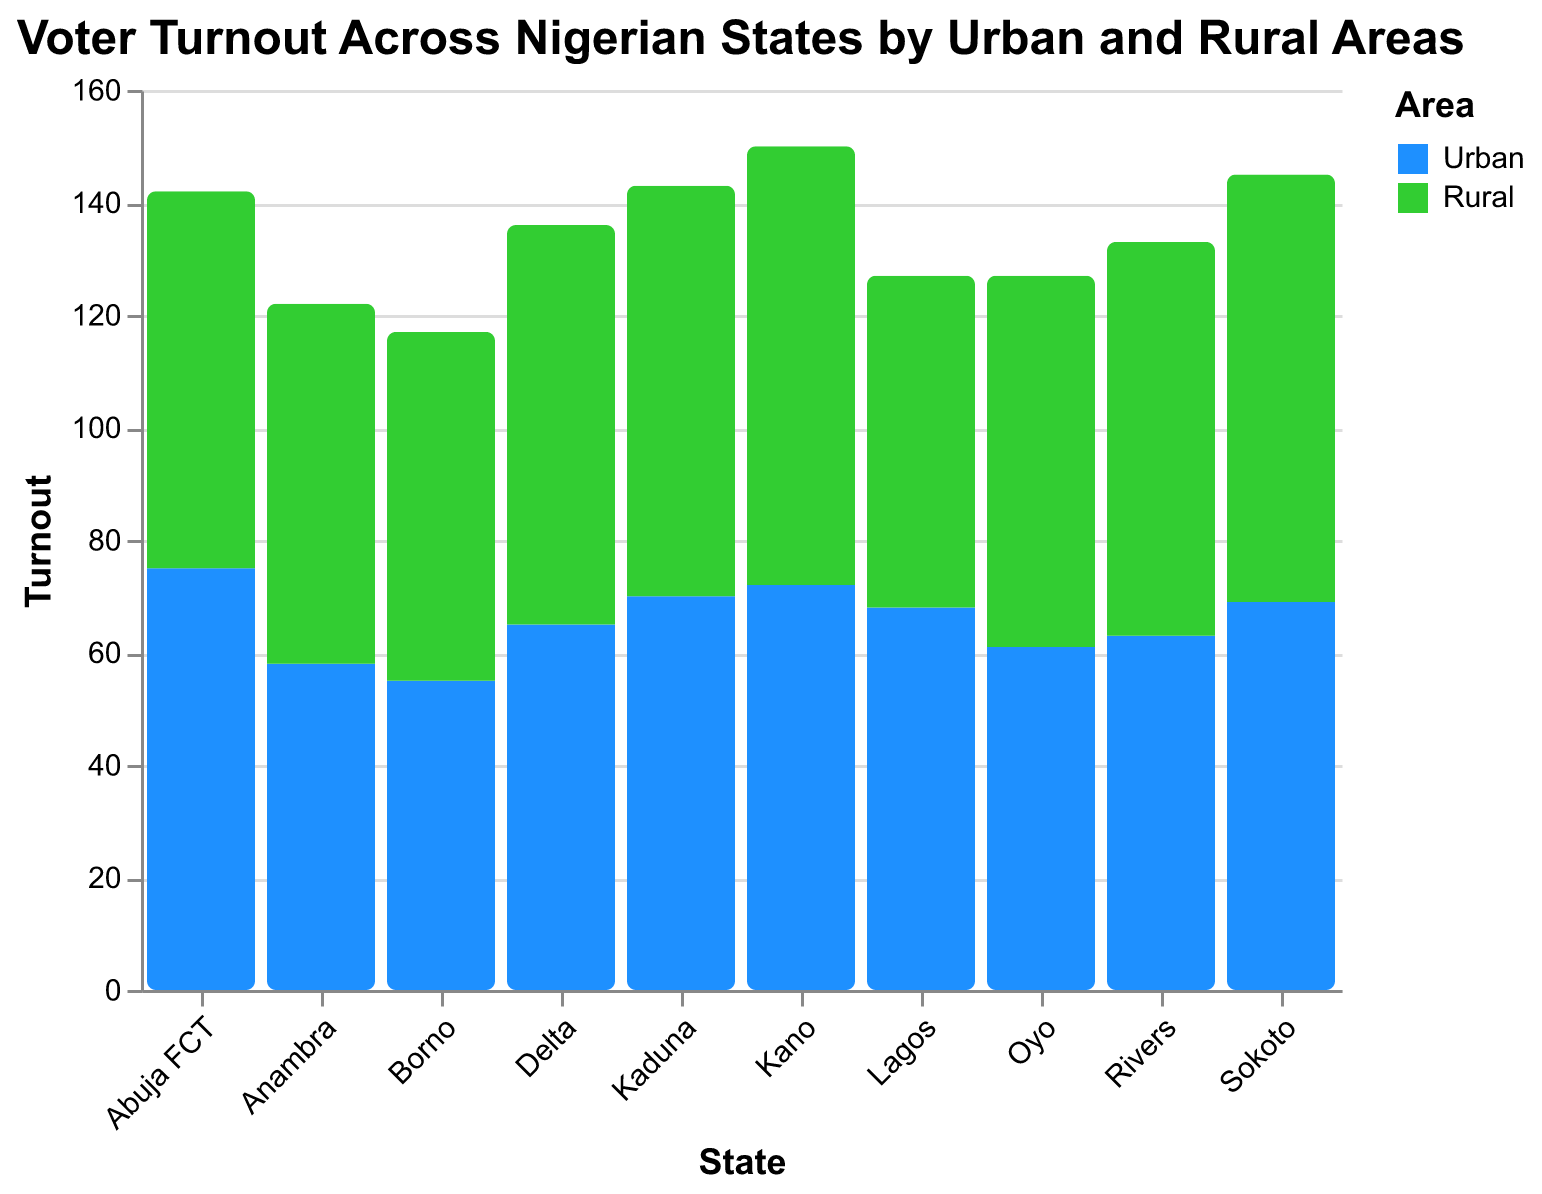What is the voter turnout in urban areas of Lagos? The voter turnout in urban areas of Lagos can be identified by finding the bar corresponding to Lagos under the color for urban areas.
Answer: 68 Which state has the highest voter turnout in rural areas? To find the state with the highest voter turnout in rural areas, compare the bar heights for all rural areas across the states.
Answer: Kano Compare the voter turnout between urban and rural areas in Rivers. Which has a higher turnout? Identify the bars for Urban and Rural areas of Rivers and compare their heights. The higher bar represents the area with the higher turnout.
Answer: Rural What is the average voter turnout in Urban areas across all states shown? Sum the voter turnouts of all Urban areas and divide by the number of states. (68 + 72 + 63 + 75 + 61 + 70 + 65 + 58 + 55 + 69) / 10 = 65.6
Answer: 65.6 Which states have a voter turnout below 60 in Urban areas? Look for bars corresponding to Urban areas that are below the 60 mark.
Answer: Anambra, Borno What is the difference in turnout between urban and rural areas in Abuja FCT? Find the turnout values for both urban and rural areas in Abuja FCT and subtract the smaller from the larger: 75 - 67
Answer: 8 What is the median voter turnout of rural areas across all states? Arrange the turnout values for rural areas in numerical order and find the middle value (or average the two middle values). (59, 62, 64, 66, 67, 70, 71, 73, 76, 78). The median is (67 + 70) / 2
Answer: 68.5 Among all states, which area has the lowest voter turnout? Compare all bars and identify the smallest one.
Answer: Borno Urban How many states have a higher turnout in rural areas compared to their urban counterparts? Count the number of states where the rural area bar is higher than the urban area bar.
Answer: 8 What is the combined voter turnout of both urban and rural areas in Kano? Add the voter turnout of both urban and rural areas in Kano. 72 + 78
Answer: 150 